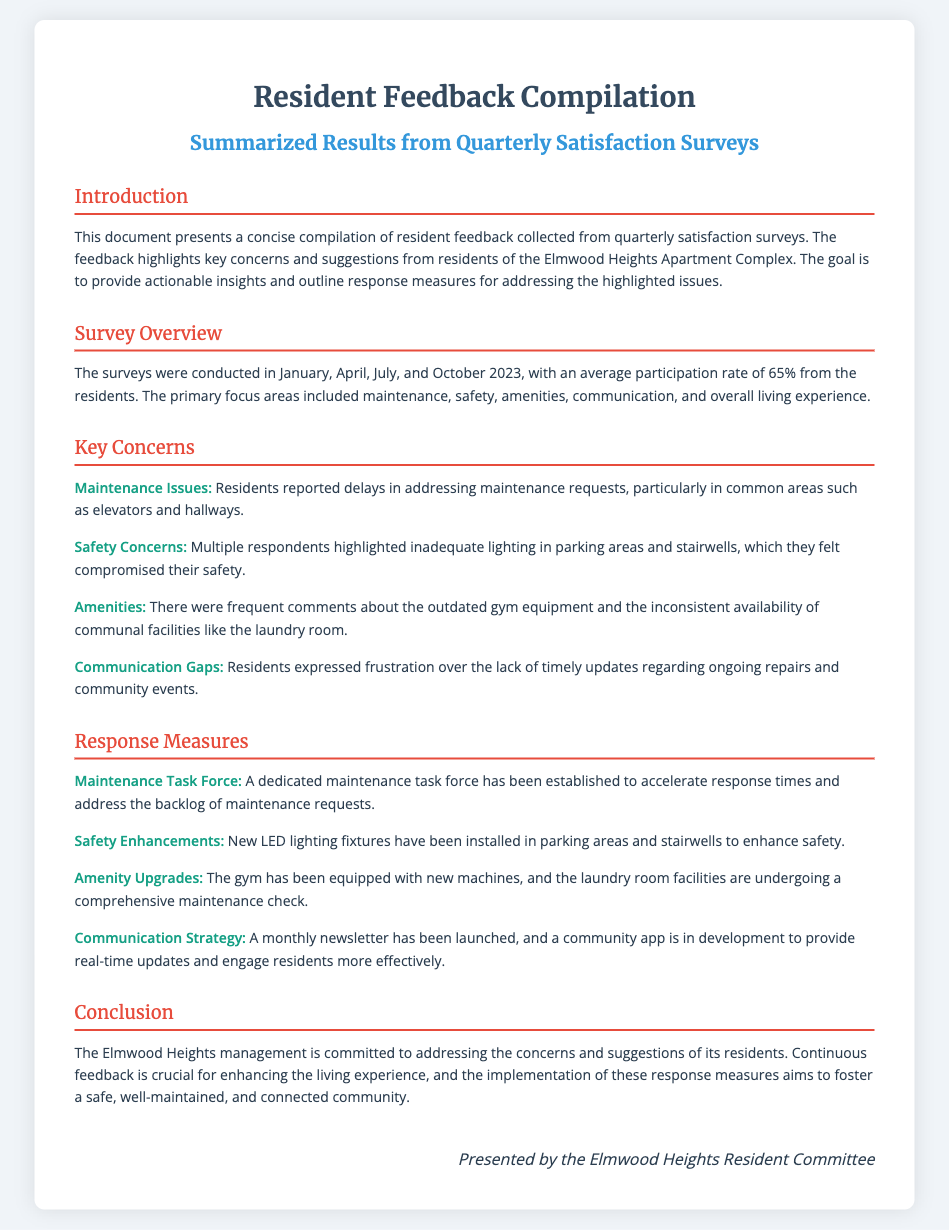what is the average participation rate for the surveys? The document states that the average participation rate was 65% from the residents.
Answer: 65% which month did the surveys take place? The surveys were conducted in January, April, July, and October 2023.
Answer: January, April, July, October what key concern relates to inadequate lighting? Residents highlighted inadequate lighting in parking areas and stairwells, which compromised their safety.
Answer: Safety Concerns what measure was taken to enhance safety? New LED lighting fixtures have been installed in parking areas and stairwells to enhance safety.
Answer: LED lighting fixtures what community improvement is being developed? A community app is in development to provide real-time updates and engage residents more effectively.
Answer: Community app what type of task force was established? A dedicated maintenance task force has been established to accelerate response times and address the backlog of maintenance requests.
Answer: Maintenance Task Force how often will the newsletter be published? The document mentions a monthly newsletter has been launched.
Answer: Monthly what is a suggested upgrade mentioned for the gym? The document states that the gym has been equipped with new machines as an upgrade.
Answer: New machines who presented the diploma? The diploma was presented by the Elmwood Heights Resident Committee.
Answer: Elmwood Heights Resident Committee 